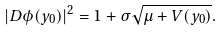Convert formula to latex. <formula><loc_0><loc_0><loc_500><loc_500>\left | D \phi ( y _ { 0 } ) \right | ^ { 2 } = 1 + \sigma \sqrt { \mu + V ( y _ { 0 } ) } .</formula> 